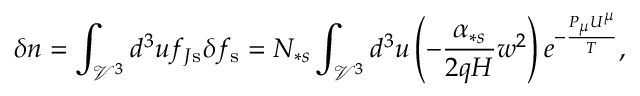<formula> <loc_0><loc_0><loc_500><loc_500>\delta n = \int _ { \mathcal { V } ^ { 3 } } d ^ { 3 } u f _ { J s } \delta f _ { s } = N _ { \ast s } \int _ { \mathcal { V } ^ { 3 } } d ^ { 3 } u \left ( - \frac { \alpha _ { \ast s } } { 2 q H } w ^ { 2 } \right ) e ^ { - \frac { P _ { \mu } U ^ { \mu } } { T } } ,</formula> 